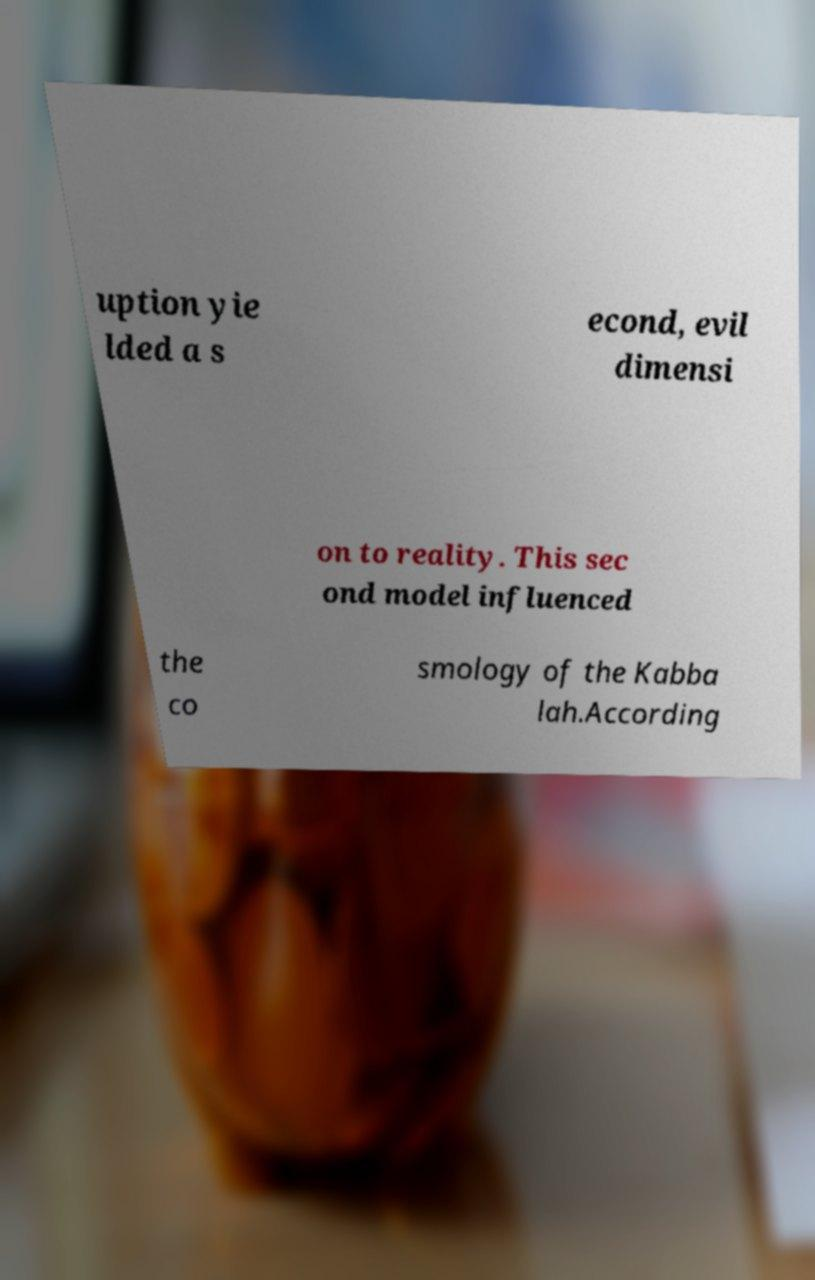Could you extract and type out the text from this image? uption yie lded a s econd, evil dimensi on to reality. This sec ond model influenced the co smology of the Kabba lah.According 